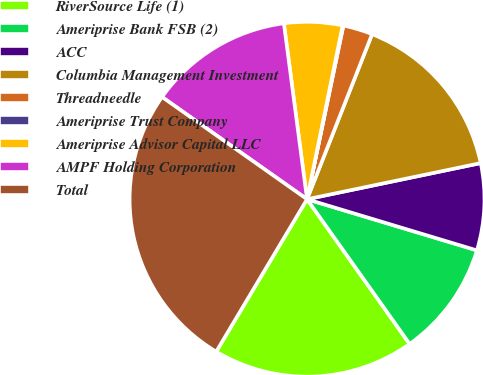Convert chart to OTSL. <chart><loc_0><loc_0><loc_500><loc_500><pie_chart><fcel>RiverSource Life (1)<fcel>Ameriprise Bank FSB (2)<fcel>ACC<fcel>Columbia Management Investment<fcel>Threadneedle<fcel>Ameriprise Trust Company<fcel>Ameriprise Advisor Capital LLC<fcel>AMPF Holding Corporation<fcel>Total<nl><fcel>18.37%<fcel>10.53%<fcel>7.92%<fcel>15.76%<fcel>2.69%<fcel>0.07%<fcel>5.3%<fcel>13.14%<fcel>26.22%<nl></chart> 